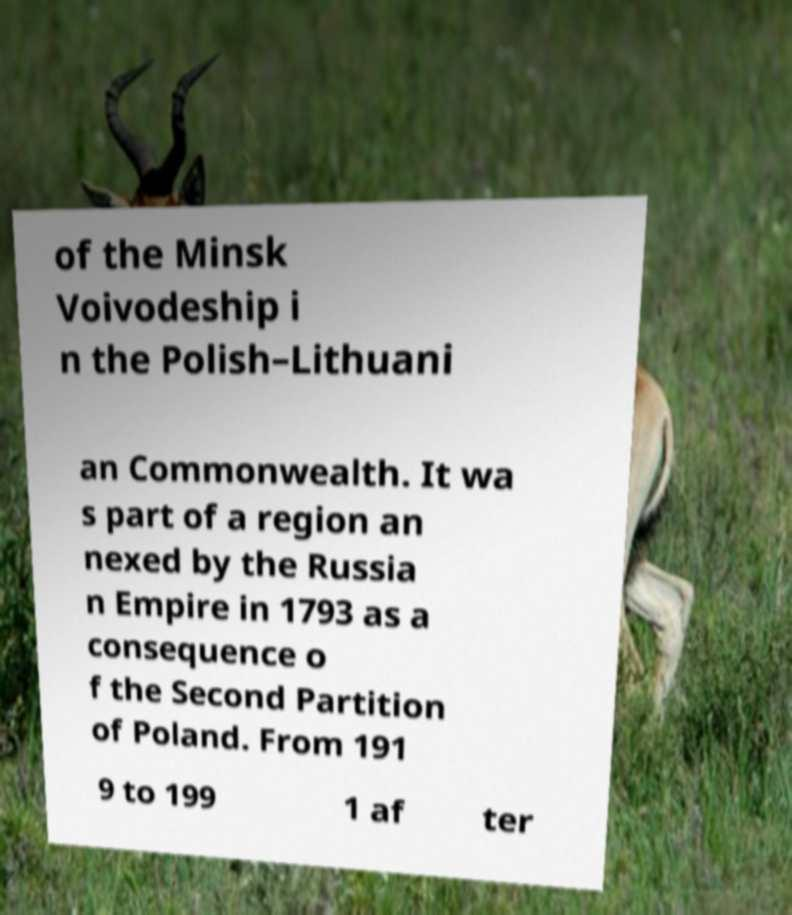What messages or text are displayed in this image? I need them in a readable, typed format. of the Minsk Voivodeship i n the Polish–Lithuani an Commonwealth. It wa s part of a region an nexed by the Russia n Empire in 1793 as a consequence o f the Second Partition of Poland. From 191 9 to 199 1 af ter 